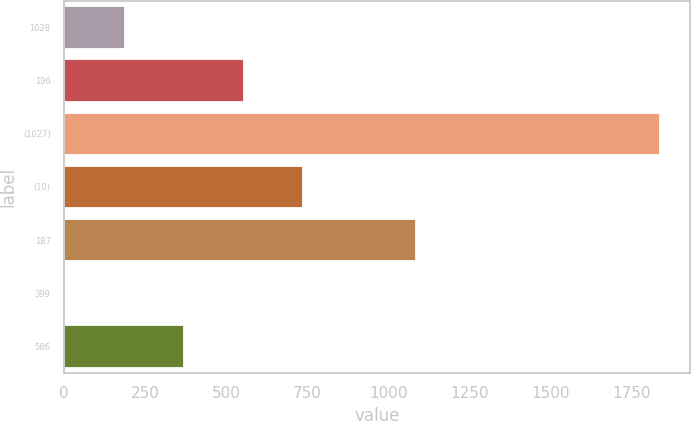Convert chart to OTSL. <chart><loc_0><loc_0><loc_500><loc_500><bar_chart><fcel>1028<fcel>196<fcel>(1027)<fcel>(10)<fcel>187<fcel>399<fcel>586<nl><fcel>187.82<fcel>554.46<fcel>1837.7<fcel>737.78<fcel>1084.2<fcel>4.5<fcel>371.14<nl></chart> 